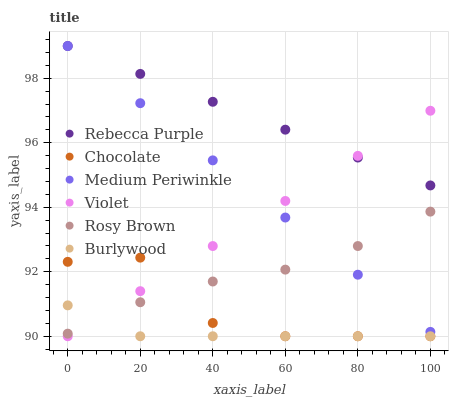Does Burlywood have the minimum area under the curve?
Answer yes or no. Yes. Does Rebecca Purple have the maximum area under the curve?
Answer yes or no. Yes. Does Rosy Brown have the minimum area under the curve?
Answer yes or no. No. Does Rosy Brown have the maximum area under the curve?
Answer yes or no. No. Is Medium Periwinkle the smoothest?
Answer yes or no. Yes. Is Chocolate the roughest?
Answer yes or no. Yes. Is Rosy Brown the smoothest?
Answer yes or no. No. Is Rosy Brown the roughest?
Answer yes or no. No. Does Burlywood have the lowest value?
Answer yes or no. Yes. Does Rosy Brown have the lowest value?
Answer yes or no. No. Does Rebecca Purple have the highest value?
Answer yes or no. Yes. Does Rosy Brown have the highest value?
Answer yes or no. No. Is Rosy Brown less than Rebecca Purple?
Answer yes or no. Yes. Is Medium Periwinkle greater than Chocolate?
Answer yes or no. Yes. Does Rebecca Purple intersect Violet?
Answer yes or no. Yes. Is Rebecca Purple less than Violet?
Answer yes or no. No. Is Rebecca Purple greater than Violet?
Answer yes or no. No. Does Rosy Brown intersect Rebecca Purple?
Answer yes or no. No. 